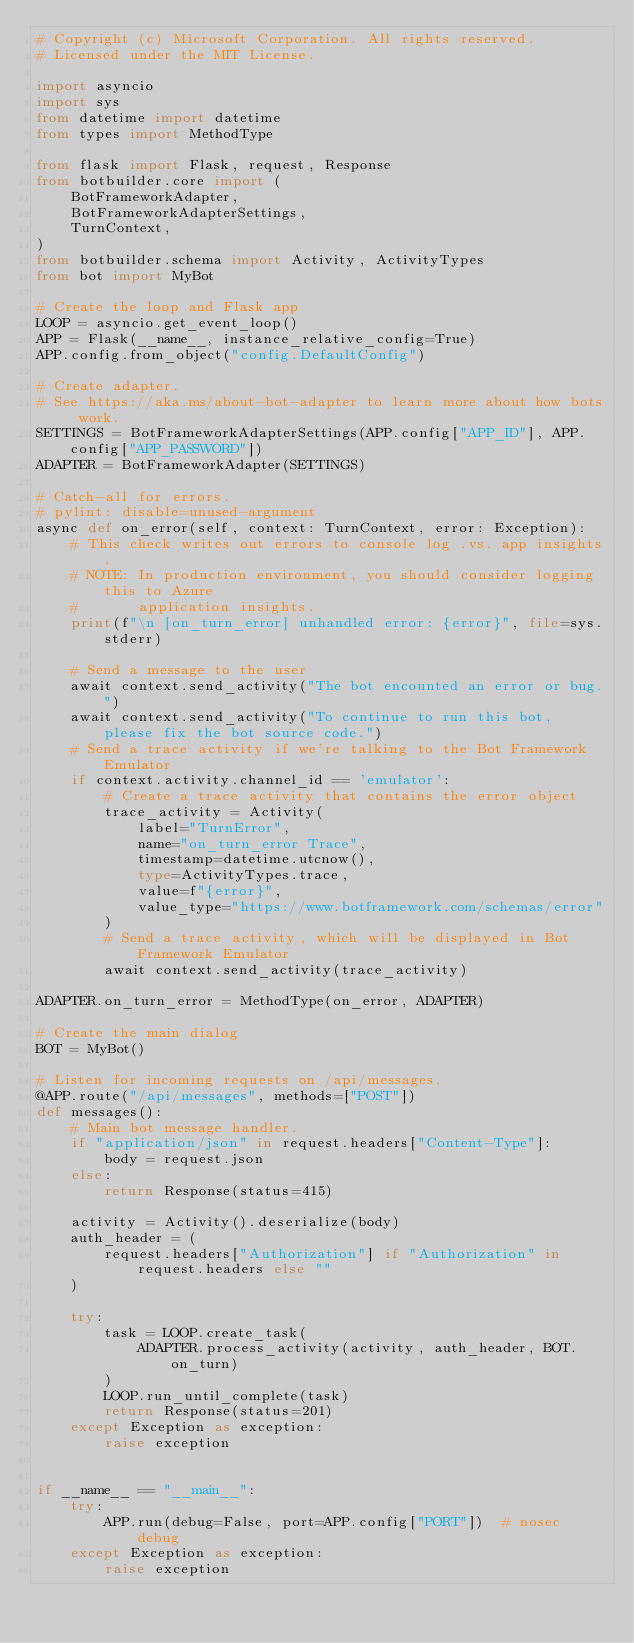<code> <loc_0><loc_0><loc_500><loc_500><_Python_># Copyright (c) Microsoft Corporation. All rights reserved.
# Licensed under the MIT License.

import asyncio
import sys
from datetime import datetime
from types import MethodType

from flask import Flask, request, Response
from botbuilder.core import (
    BotFrameworkAdapter,
    BotFrameworkAdapterSettings,
    TurnContext,
)
from botbuilder.schema import Activity, ActivityTypes
from bot import MyBot

# Create the loop and Flask app
LOOP = asyncio.get_event_loop()
APP = Flask(__name__, instance_relative_config=True)
APP.config.from_object("config.DefaultConfig")

# Create adapter.
# See https://aka.ms/about-bot-adapter to learn more about how bots work.
SETTINGS = BotFrameworkAdapterSettings(APP.config["APP_ID"], APP.config["APP_PASSWORD"])
ADAPTER = BotFrameworkAdapter(SETTINGS)

# Catch-all for errors.
# pylint: disable=unused-argument
async def on_error(self, context: TurnContext, error: Exception):
    # This check writes out errors to console log .vs. app insights.
    # NOTE: In production environment, you should consider logging this to Azure
    #       application insights.
    print(f"\n [on_turn_error] unhandled error: {error}", file=sys.stderr)

    # Send a message to the user
    await context.send_activity("The bot encounted an error or bug.")
    await context.send_activity("To continue to run this bot, please fix the bot source code.")
    # Send a trace activity if we're talking to the Bot Framework Emulator
    if context.activity.channel_id == 'emulator':
        # Create a trace activity that contains the error object
        trace_activity = Activity(
            label="TurnError",
            name="on_turn_error Trace",
            timestamp=datetime.utcnow(),
            type=ActivityTypes.trace,
            value=f"{error}",
            value_type="https://www.botframework.com/schemas/error"
        )
        # Send a trace activity, which will be displayed in Bot Framework Emulator
        await context.send_activity(trace_activity)

ADAPTER.on_turn_error = MethodType(on_error, ADAPTER)

# Create the main dialog
BOT = MyBot()

# Listen for incoming requests on /api/messages.
@APP.route("/api/messages", methods=["POST"])
def messages():
    # Main bot message handler.
    if "application/json" in request.headers["Content-Type"]:
        body = request.json
    else:
        return Response(status=415)

    activity = Activity().deserialize(body)
    auth_header = (
        request.headers["Authorization"] if "Authorization" in request.headers else ""
    )

    try:
        task = LOOP.create_task(
            ADAPTER.process_activity(activity, auth_header, BOT.on_turn)
        )
        LOOP.run_until_complete(task)
        return Response(status=201)
    except Exception as exception:
        raise exception


if __name__ == "__main__":
    try:
        APP.run(debug=False, port=APP.config["PORT"])  # nosec debug
    except Exception as exception:
        raise exception
</code> 